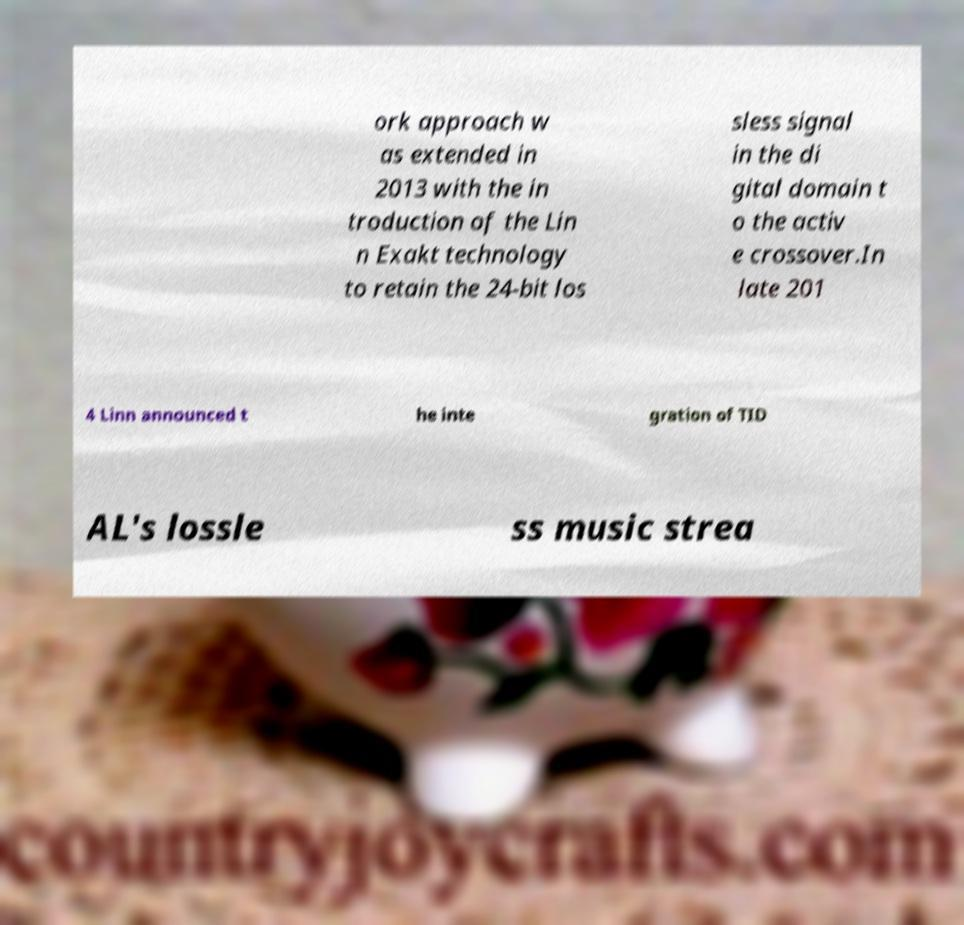I need the written content from this picture converted into text. Can you do that? ork approach w as extended in 2013 with the in troduction of the Lin n Exakt technology to retain the 24-bit los sless signal in the di gital domain t o the activ e crossover.In late 201 4 Linn announced t he inte gration of TID AL's lossle ss music strea 